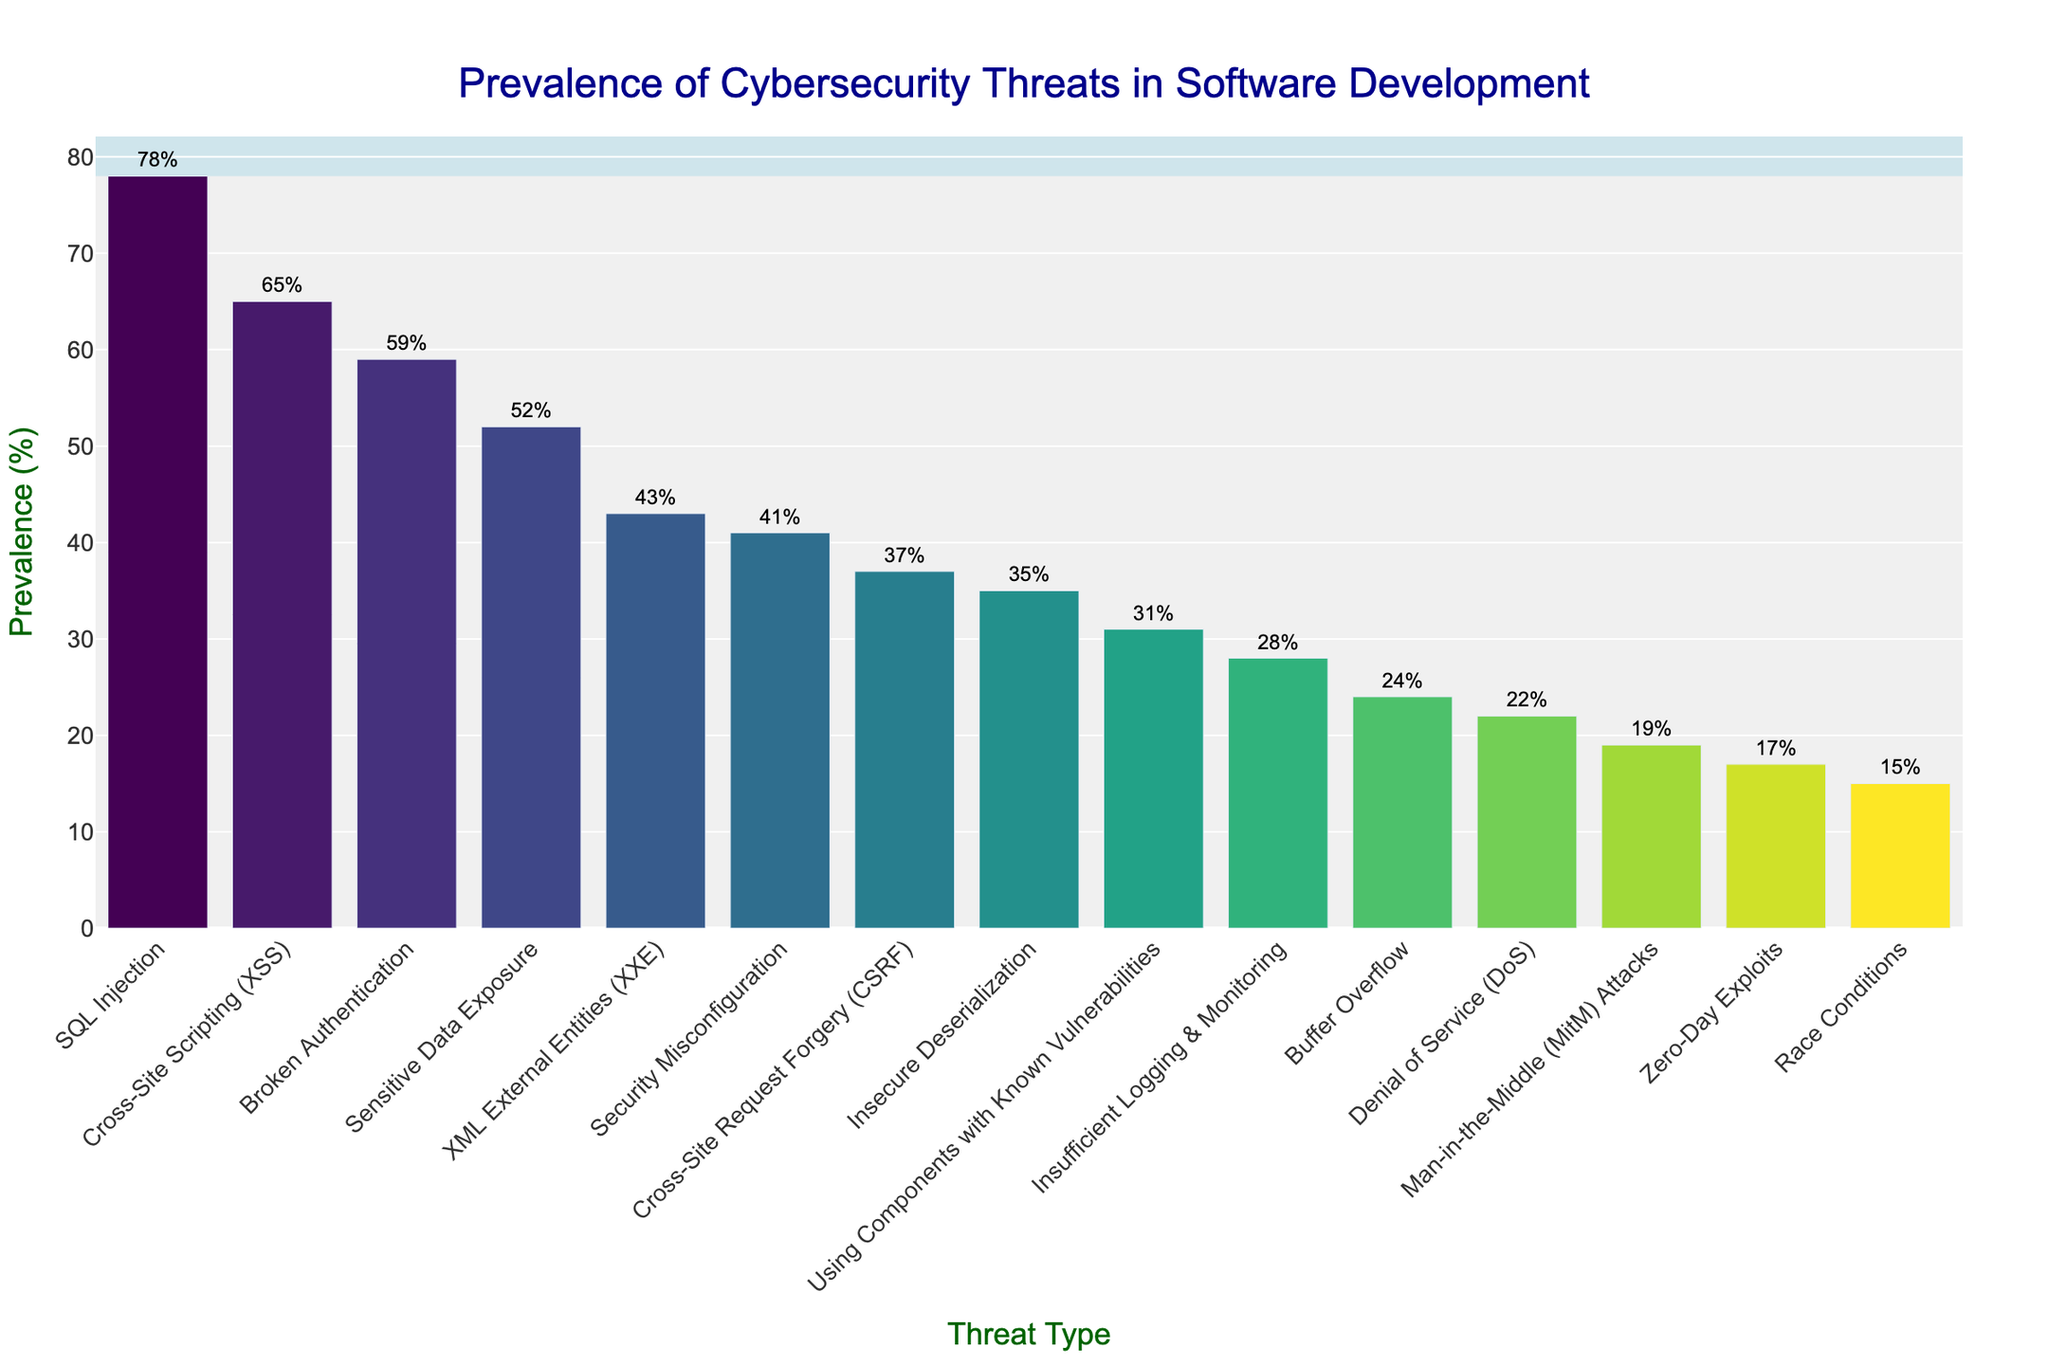What is the prevalence of SQL Injection compared to Cross-Site Scripting (XSS)? SQL Injection has a prevalence of 78%, and Cross-Site Scripting (XSS) has a prevalence of 65%. Therefore, SQL Injection is more prevalent than Cross-Site Scripting (XSS).
Answer: SQL Injection is 13% more prevalent than Cross-Site Scripting (XSS) Which threat type has the lowest prevalence? Look at the bottom of the bar chart to find the shortest bar. The shortest bar corresponds to "Race Conditions" with a prevalence of 15%.
Answer: Race Conditions How much more prevalent is Security Misconfiguration compared to Insufficient Logging & Monitoring? Security Misconfiguration has a prevalence of 41%, whereas Insufficient Logging & Monitoring has 28%. Calculate the difference: 41% - 28% = 13%.
Answer: 13% What is the total prevalence percentage of the top three threats? The top three threats are SQL Injection (78%), Cross-Site Scripting (XSS) (65%), and Broken Authentication (59%). Sum them: 78% + 65% + 59% = 202%.
Answer: 202% Which threat type related to data exposure has a higher prevalence, Sensitive Data Exposure or XML External Entities (XXE)? Sensitive Data Exposure has a prevalence of 52%, whereas XML External Entities have a prevalence of 43%. Therefore, Sensitive Data Exposure is more prevalent.
Answer: Sensitive Data Exposure What is the combined prevalence of denial-of-service-related threats (DoS and MitM attacks)? Denial of Service (DoS) has a prevalence of 22%, and Man-in-the-Middle (MitM) Attacks have 19%. Sum them: 22% + 19% = 41%.
Answer: 41% How does the prevalence of Insecure Deserialization compare with Using Components with Known Vulnerabilities? Insecure Deserialization has a prevalence of 35%, while Using Components with Known Vulnerabilities has 31%. Insecure Deserialization is more prevalent.
Answer: Insecure Deserialization is 4% more prevalent What is the average prevalence of all threat types listed? Sum all the prevalences and divide by the number of threat types. The total sum is 615% for 15 threat types. Calculate the average: 615% / 15 = 41%.
Answer: 41% Which threat has less prevalence than Broken Authentication but more than XML External Entities (XXE)? Broken Authentication has a prevalence of 59%, and XML External Entities (XXE) have 43%. The threat between these values is Sensitive Data Exposure with 52%.
Answer: Sensitive Data Exposure 